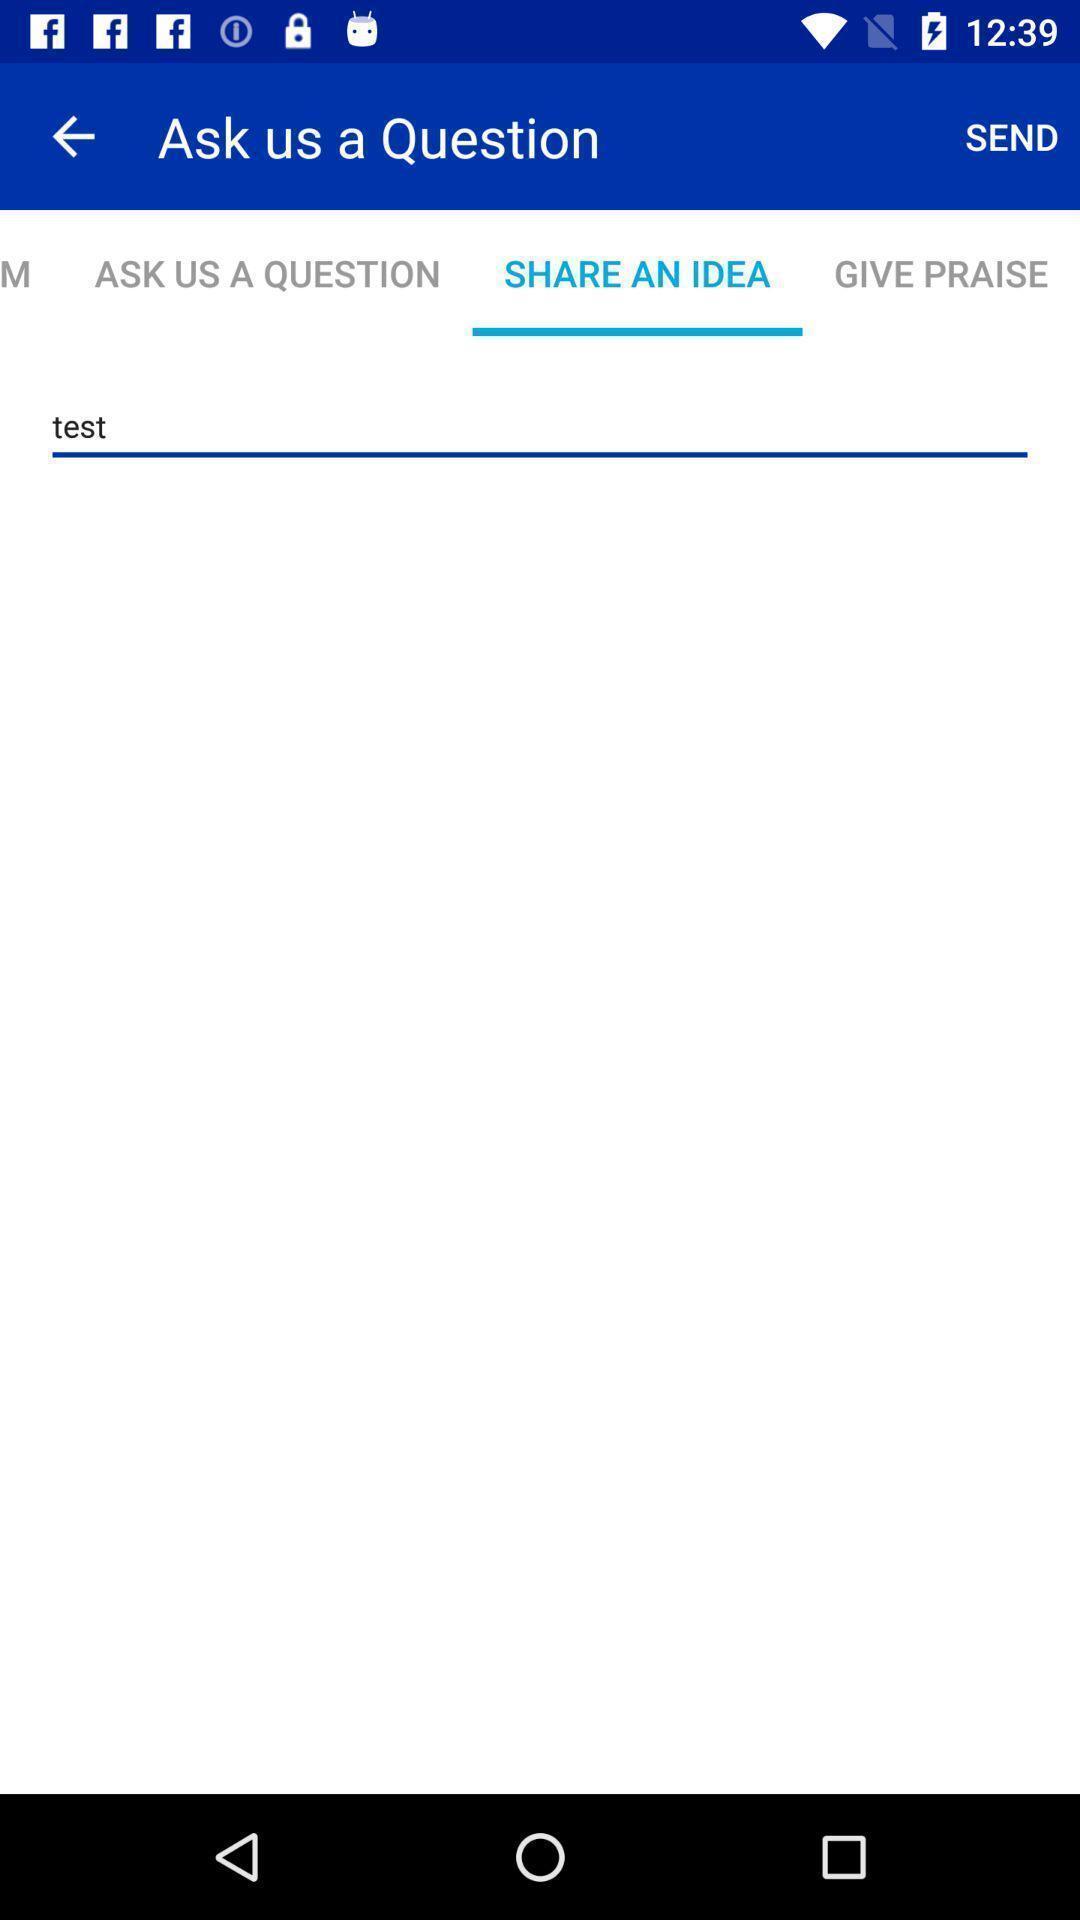Summarize the main components in this picture. Page showing share an idea. 